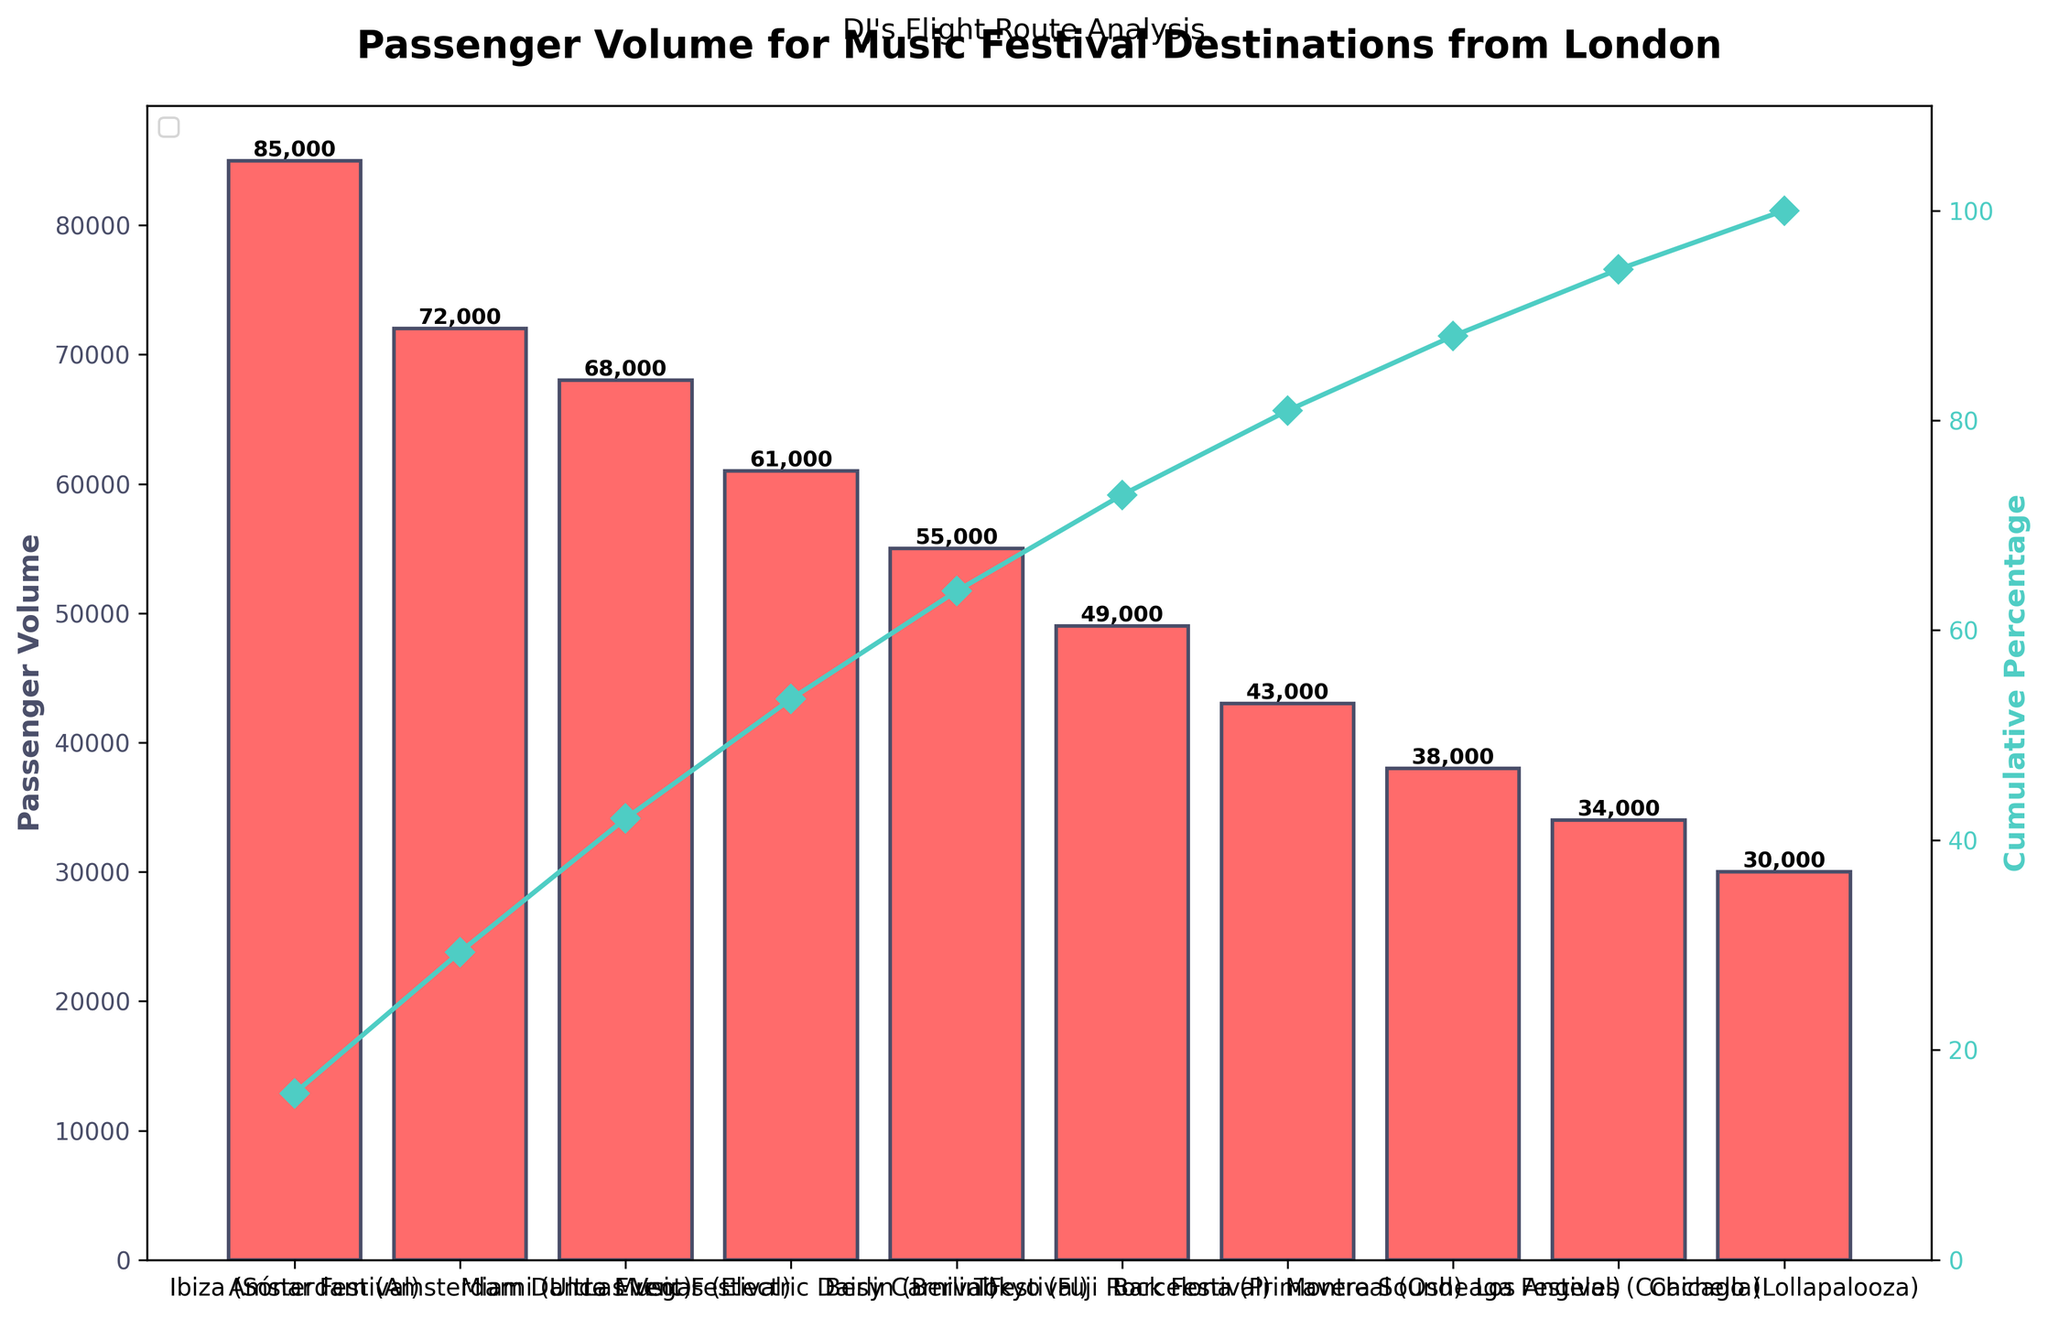What's the highest passenger volume route? The highest passenger volume can be determined by identifying the bar with the greatest height. In this chart, Ibiza (Sónar Festival) is the first bar, indicating it has the highest passenger volume of 85,000.
Answer: Ibiza (Sónar Festival) What is the cumulative percentage for Tokyo (Fuji Rock Festival)? To find the cumulative percentage for Tokyo, look to the plot line above the Tokyo bar. This line shows the cumulative percentage at each point. For Tokyo, the percentage is approximately 76%, as directly reading from the axis.
Answer: 76% Which destination has the lowest passenger volume? The destination with the lowest passenger volume can be found by locating the shortest bar. In this chart, Chicago (Lollapalooza) is the last bar and has the lowest volume of 30,000.
Answer: Chicago (Lollapalooza) What is the total passenger volume for all the listed destinations? The total passenger volume is the sum of all individual volumes listed in the chart. Summing the values: 85000 + 72000 + 68000 + 61000 + 55000 + 49000 + 43000 + 38000 + 34000 + 30000 = 535,000.
Answer: 535,000 How many destinations are analyzed in the chart? Count the number of distinct bars on the x-axis of the chart. Each bar represents a destination. There are 10 bars in total.
Answer: 10 Which destination's cumulative percentage first exceeds 50%? To find this, identify the destination where the cumulative percentage line first crosses above the 50% mark. This occurs above the Miami (Ultra Music Festival) bar, which is the third bar.
Answer: Miami (Ultra Music Festival) By how much does the passenger volume for Ibiza exceed that for Chicago? Subtract the passenger volume of Chicago from Ibiza: 85,000 (Ibiza) - 30,000 (Chicago) = 55,000.
Answer: 55,000 What is the approximate cumulative percentage after the fourth highest destination? Locate the fourth highest destination, which is Las Vegas (Electric Daisy Carnival), and look at where the cumulative percentage line stands after this point. It is roughly 69%.
Answer: 69% Which two destinations together make up more than 25% of the total passenger volume? Identify pairs of destinations and calculate their combined percentage of the total volume: Ibiza (85,000) + Amsterdam (72,000) = 157,000. Compute as (157,000 / 535,000) * 100 ≈ 29.4%, which exceeds 25%.
Answer: Ibiza and Amsterdam What is the difference in cumulative percentage between Berlin (Berlin Festival) and Barcelona (Primavera Sound)? Find the cumulative percentages of both destinations. Berlin is around 65%, and Barcelona is around 83%. Subtracting them gives 83% - 65% = 18%.
Answer: 18% 